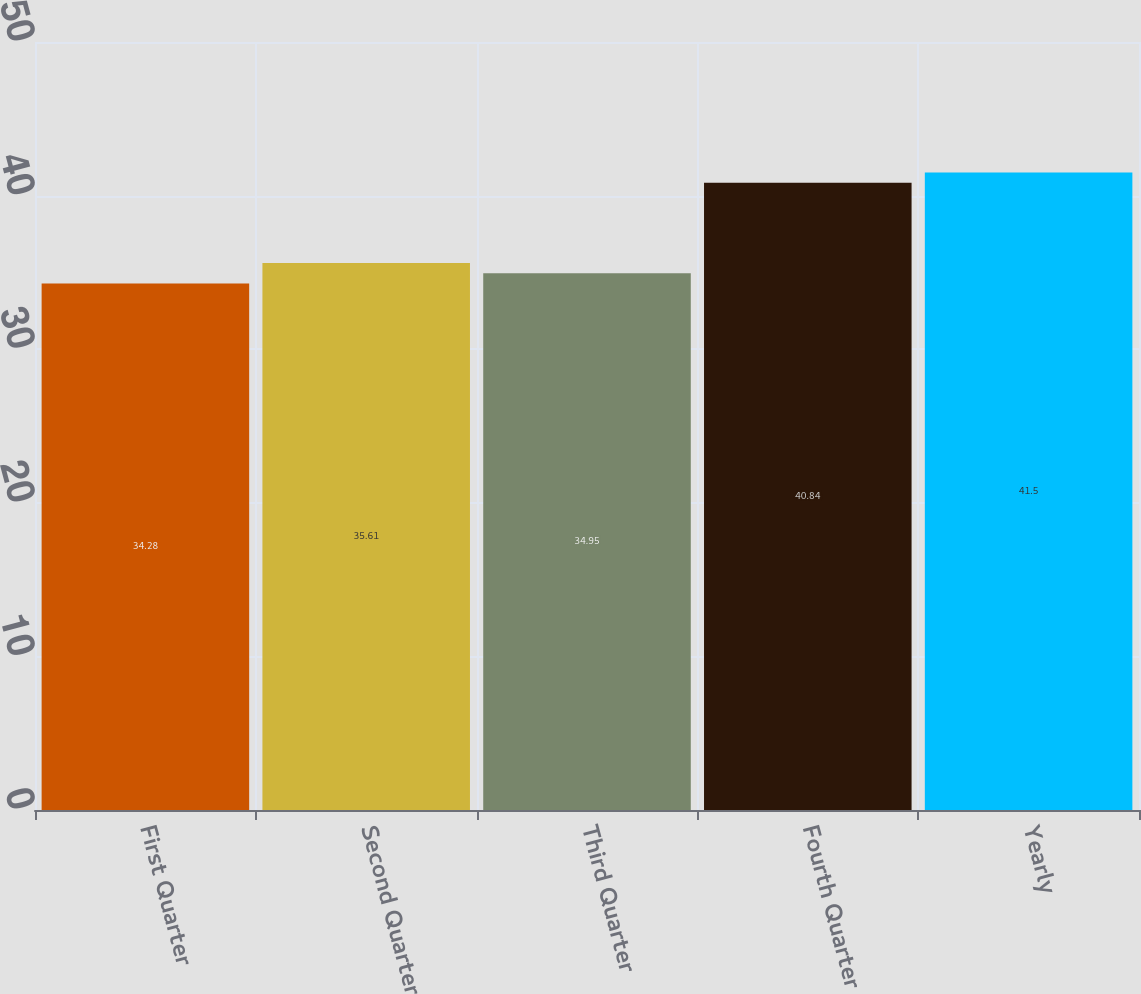Convert chart to OTSL. <chart><loc_0><loc_0><loc_500><loc_500><bar_chart><fcel>First Quarter<fcel>Second Quarter<fcel>Third Quarter<fcel>Fourth Quarter<fcel>Yearly<nl><fcel>34.28<fcel>35.61<fcel>34.95<fcel>40.84<fcel>41.5<nl></chart> 